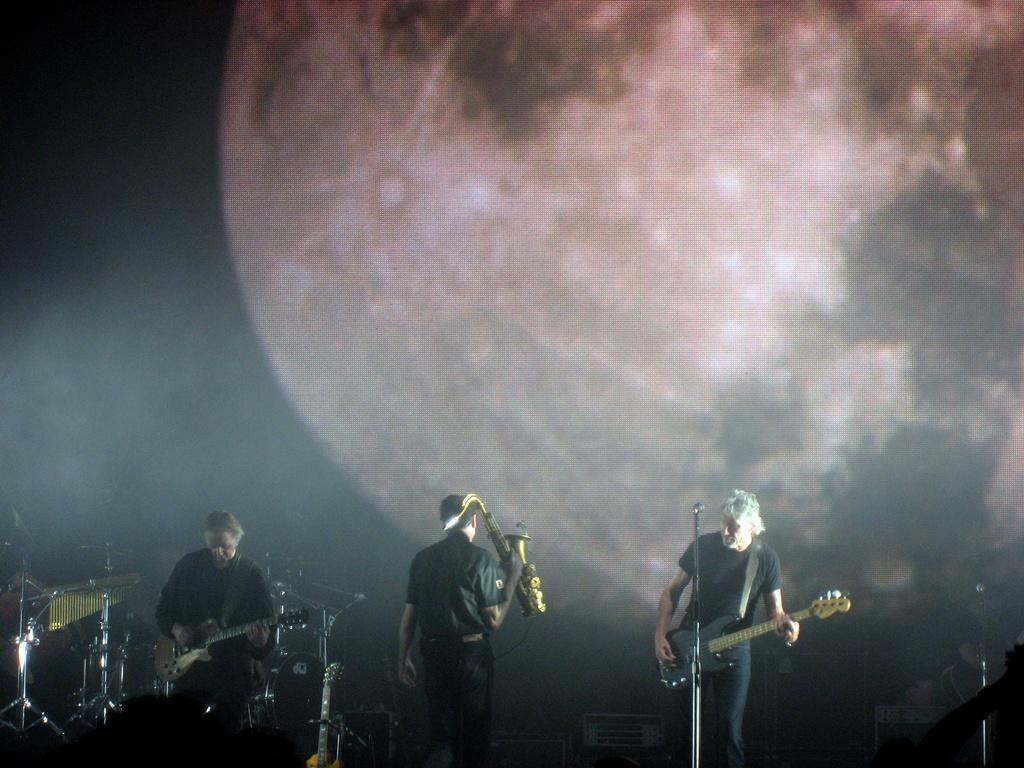Please provide a concise description of this image. In this image it seems like it is a music concert. On the left side there is a person playing the guitar in front of the mic. On the left side there is another person playing the guitar. In the middle there is a person who is holding the trumpet. 